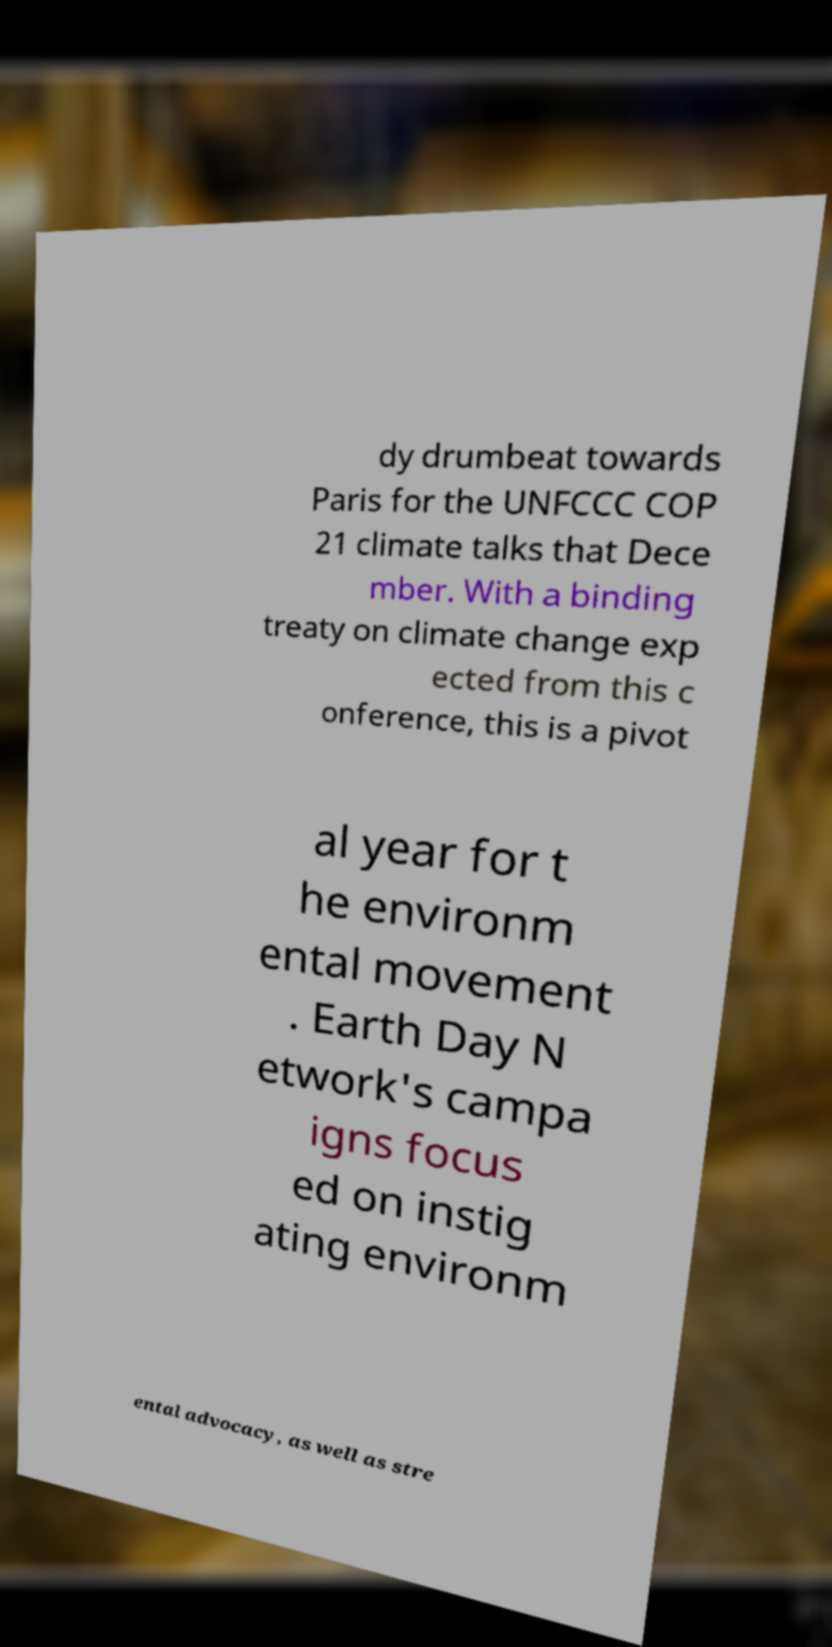For documentation purposes, I need the text within this image transcribed. Could you provide that? dy drumbeat towards Paris for the UNFCCC COP 21 climate talks that Dece mber. With a binding treaty on climate change exp ected from this c onference, this is a pivot al year for t he environm ental movement . Earth Day N etwork's campa igns focus ed on instig ating environm ental advocacy, as well as stre 